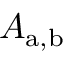Convert formula to latex. <formula><loc_0><loc_0><loc_500><loc_500>A _ { a , b }</formula> 